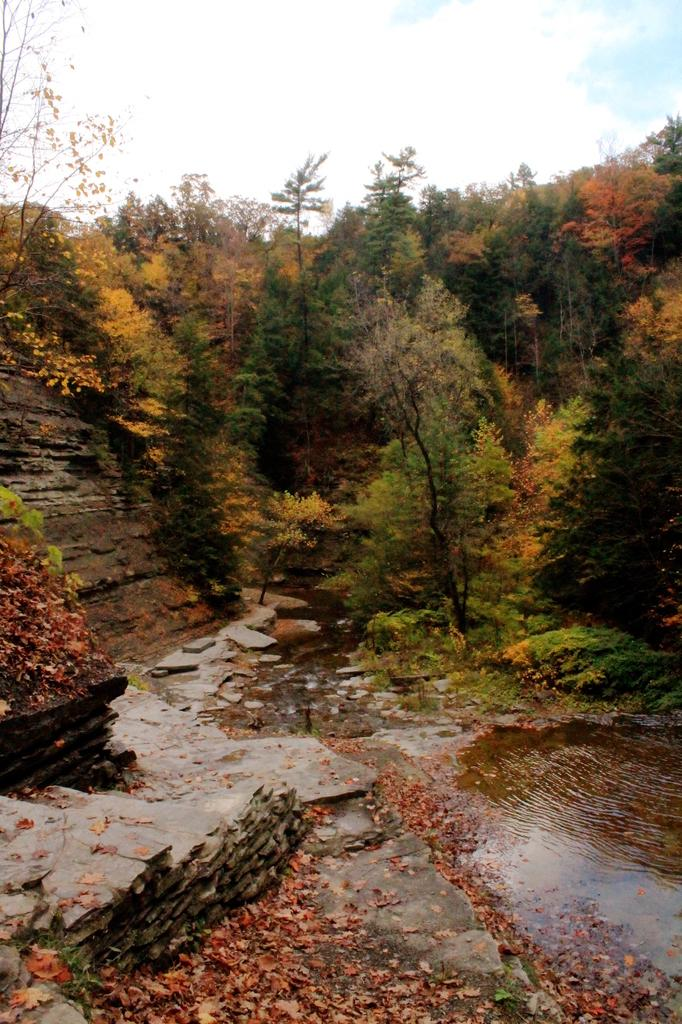What is covering the ground in the image? There are shredded leaves on the ground in the image. What else can be seen in the image besides the leaves? Water, rocks, trees, and the sky are visible in the image. Can you describe the sky in the image? The sky is visible in the background of the image, and clouds are present. What invention is being advertised in the image? There is no invention being advertised in the image; it primarily features natural elements like leaves, water, rocks, trees, and the sky. 